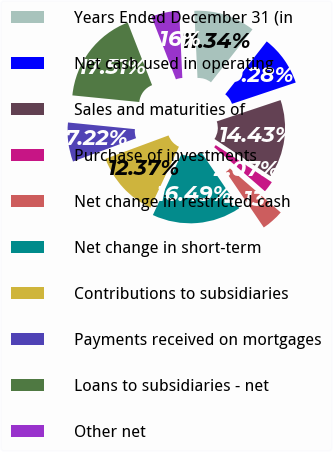Convert chart to OTSL. <chart><loc_0><loc_0><loc_500><loc_500><pie_chart><fcel>Years Ended December 31 (in<fcel>Net cash used in operating<fcel>Sales and maturities of<fcel>Purchase of investments<fcel>Net change in restricted cash<fcel>Net change in short-term<fcel>Contributions to subsidiaries<fcel>Payments received on mortgages<fcel>Loans to subsidiaries - net<fcel>Other net<nl><fcel>11.34%<fcel>9.28%<fcel>14.43%<fcel>2.07%<fcel>4.13%<fcel>16.49%<fcel>12.37%<fcel>7.22%<fcel>17.51%<fcel>5.16%<nl></chart> 